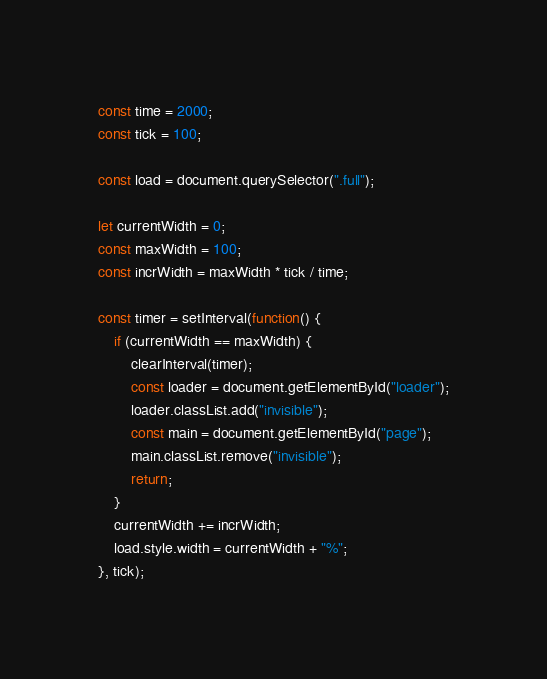Convert code to text. <code><loc_0><loc_0><loc_500><loc_500><_JavaScript_>
const time = 2000;
const tick = 100;

const load = document.querySelector(".full");

let currentWidth = 0;
const maxWidth = 100;
const incrWidth = maxWidth * tick / time; 

const timer = setInterval(function() {
    if (currentWidth == maxWidth) {
        clearInterval(timer);
        const loader = document.getElementById("loader");
        loader.classList.add("invisible");
        const main = document.getElementById("page");
        main.classList.remove("invisible");
        return;
    }
    currentWidth += incrWidth;
    load.style.width = currentWidth + "%";
}, tick);
</code> 